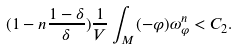<formula> <loc_0><loc_0><loc_500><loc_500>( 1 - n \frac { 1 - \delta } { \delta } ) \frac { 1 } { V } \int _ { M } ( - \varphi ) \omega _ { \varphi } ^ { n } < C _ { 2 } .</formula> 